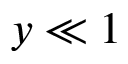Convert formula to latex. <formula><loc_0><loc_0><loc_500><loc_500>{ y \ll 1 }</formula> 